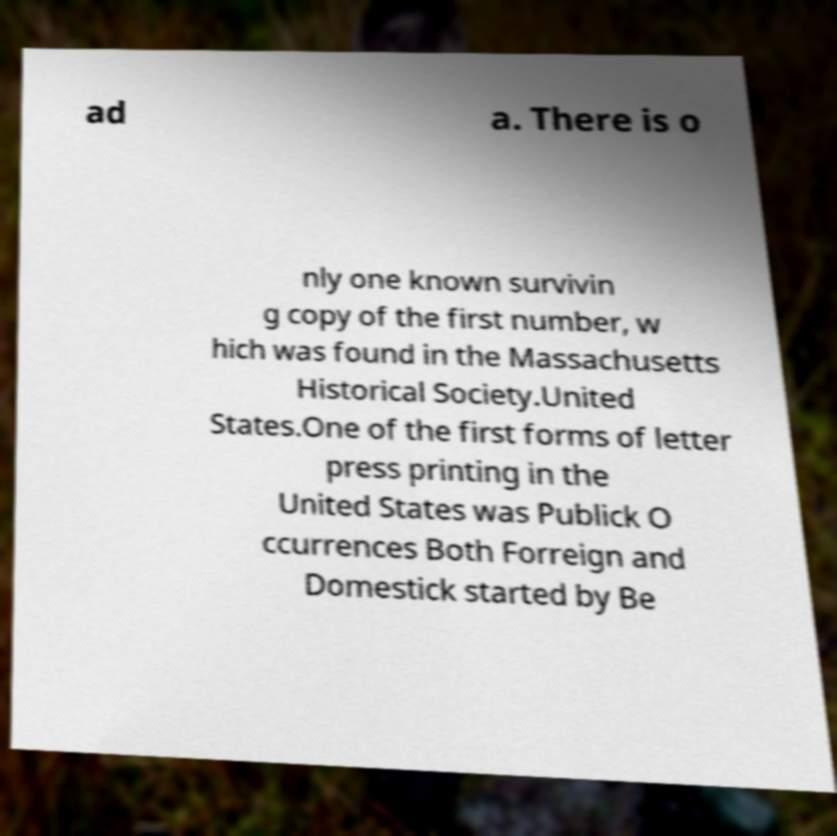For documentation purposes, I need the text within this image transcribed. Could you provide that? ad a. There is o nly one known survivin g copy of the first number, w hich was found in the Massachusetts Historical Society.United States.One of the first forms of letter press printing in the United States was Publick O ccurrences Both Forreign and Domestick started by Be 